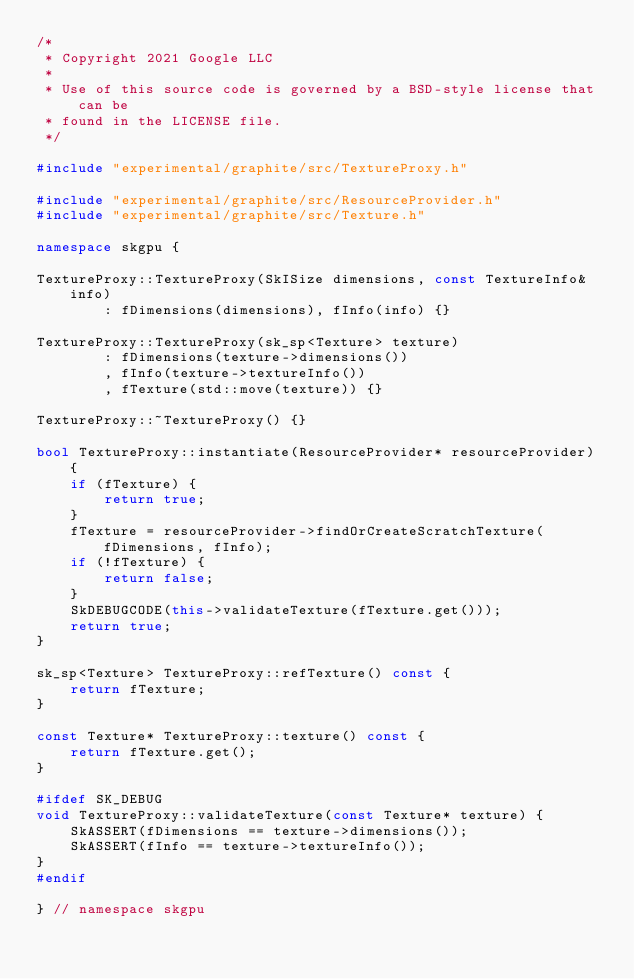Convert code to text. <code><loc_0><loc_0><loc_500><loc_500><_C++_>/*
 * Copyright 2021 Google LLC
 *
 * Use of this source code is governed by a BSD-style license that can be
 * found in the LICENSE file.
 */

#include "experimental/graphite/src/TextureProxy.h"

#include "experimental/graphite/src/ResourceProvider.h"
#include "experimental/graphite/src/Texture.h"

namespace skgpu {

TextureProxy::TextureProxy(SkISize dimensions, const TextureInfo& info)
        : fDimensions(dimensions), fInfo(info) {}

TextureProxy::TextureProxy(sk_sp<Texture> texture)
        : fDimensions(texture->dimensions())
        , fInfo(texture->textureInfo())
        , fTexture(std::move(texture)) {}

TextureProxy::~TextureProxy() {}

bool TextureProxy::instantiate(ResourceProvider* resourceProvider) {
    if (fTexture) {
        return true;
    }
    fTexture = resourceProvider->findOrCreateScratchTexture(fDimensions, fInfo);
    if (!fTexture) {
        return false;
    }
    SkDEBUGCODE(this->validateTexture(fTexture.get()));
    return true;
}

sk_sp<Texture> TextureProxy::refTexture() const {
    return fTexture;
}

const Texture* TextureProxy::texture() const {
    return fTexture.get();
}

#ifdef SK_DEBUG
void TextureProxy::validateTexture(const Texture* texture) {
    SkASSERT(fDimensions == texture->dimensions());
    SkASSERT(fInfo == texture->textureInfo());
}
#endif

} // namespace skgpu
</code> 